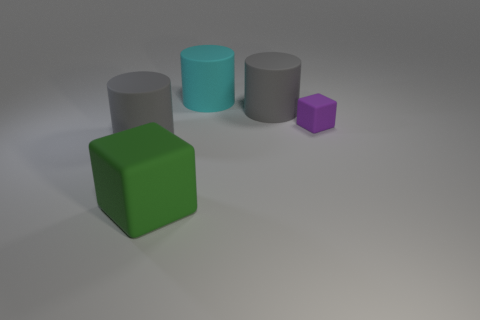Are there fewer big cylinders behind the cyan matte cylinder than small matte things that are behind the big green rubber cube?
Your answer should be compact. Yes. Is there a tiny purple object that has the same shape as the large green object?
Your response must be concise. Yes. Is the big green thing the same shape as the purple thing?
Your answer should be compact. Yes. How many large objects are either gray cylinders or yellow rubber objects?
Offer a terse response. 2. Is the number of big cyan matte things greater than the number of tiny spheres?
Ensure brevity in your answer.  Yes. The purple thing that is made of the same material as the big green block is what size?
Offer a terse response. Small. Do the gray cylinder on the left side of the green matte object and the rubber block that is to the right of the large cyan object have the same size?
Your response must be concise. No. How many objects are either blocks in front of the small rubber cube or large gray rubber objects?
Your answer should be very brief. 3. Is the number of purple matte things less than the number of large red matte things?
Provide a succinct answer. No. There is a large gray rubber object that is to the right of the big thing that is behind the big gray cylinder right of the big green matte object; what shape is it?
Your answer should be very brief. Cylinder. 